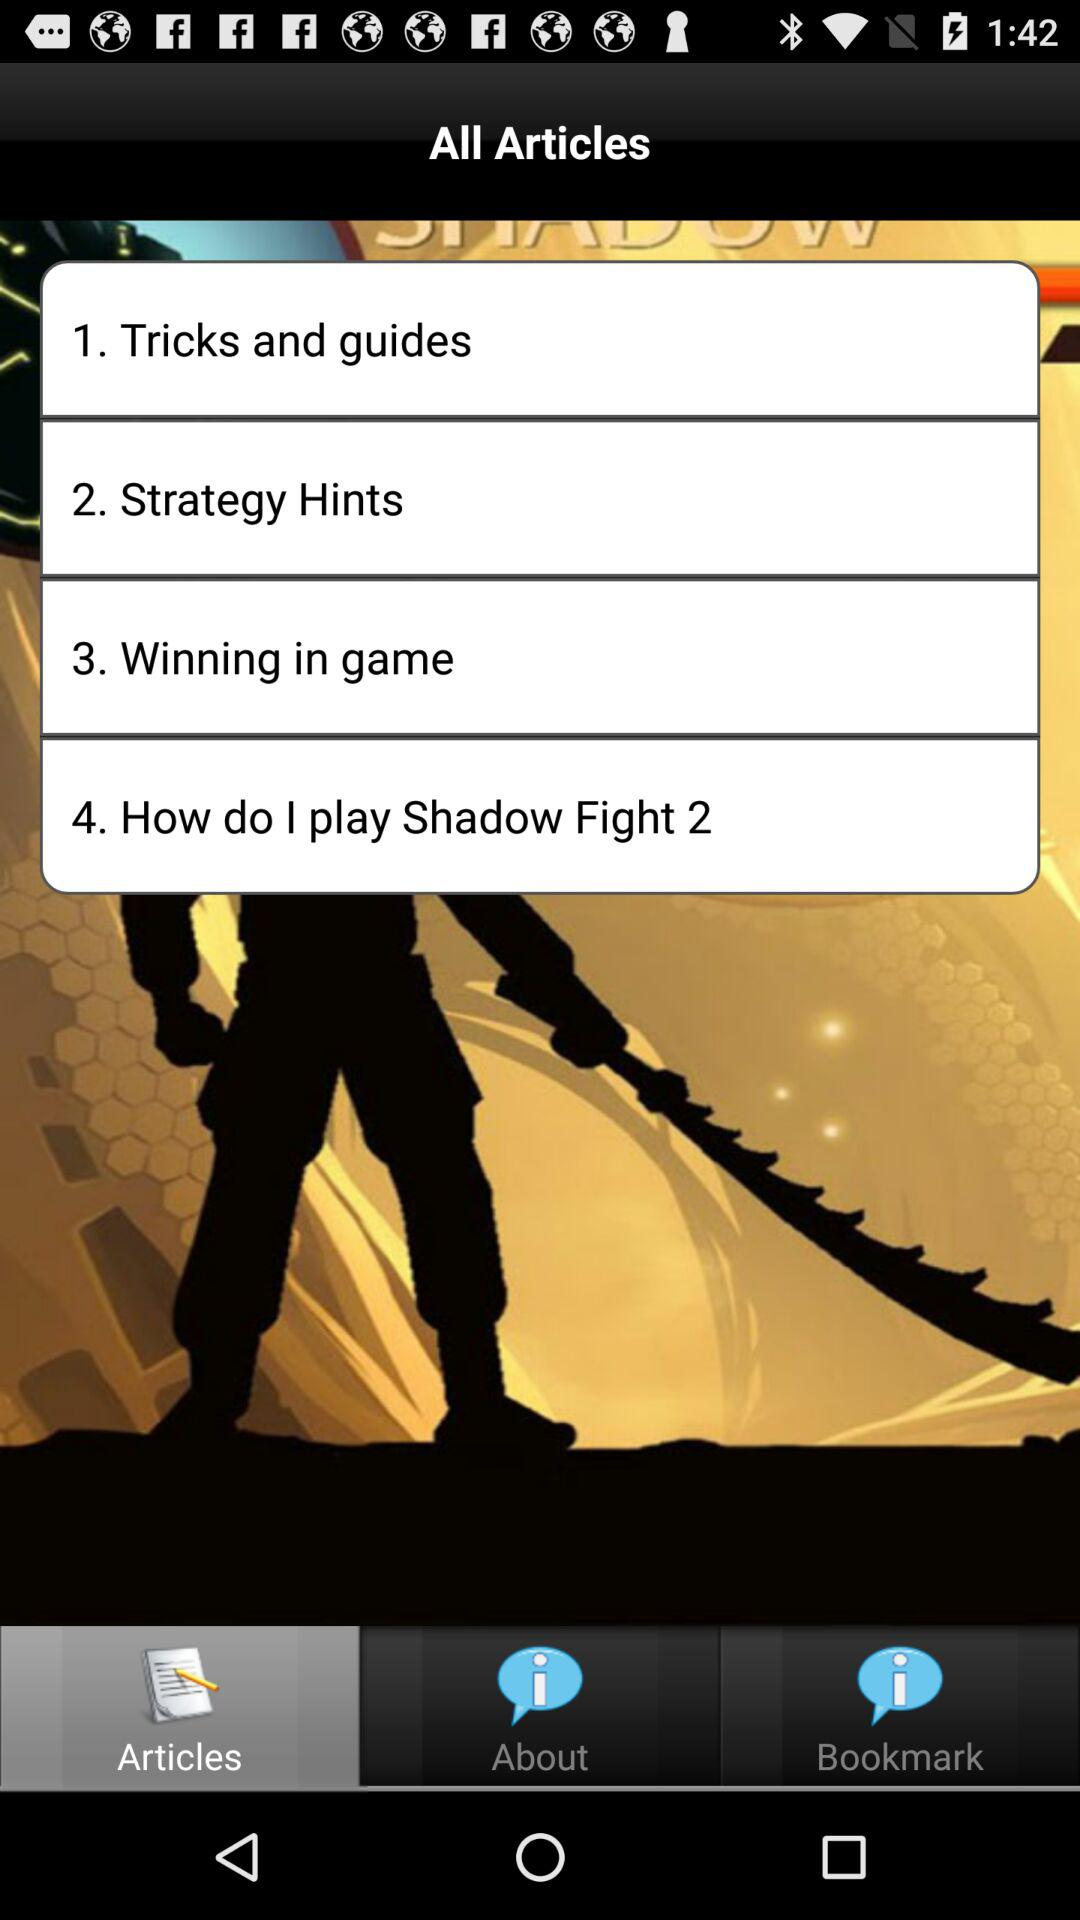How many articles are there on this page?
Answer the question using a single word or phrase. 4 